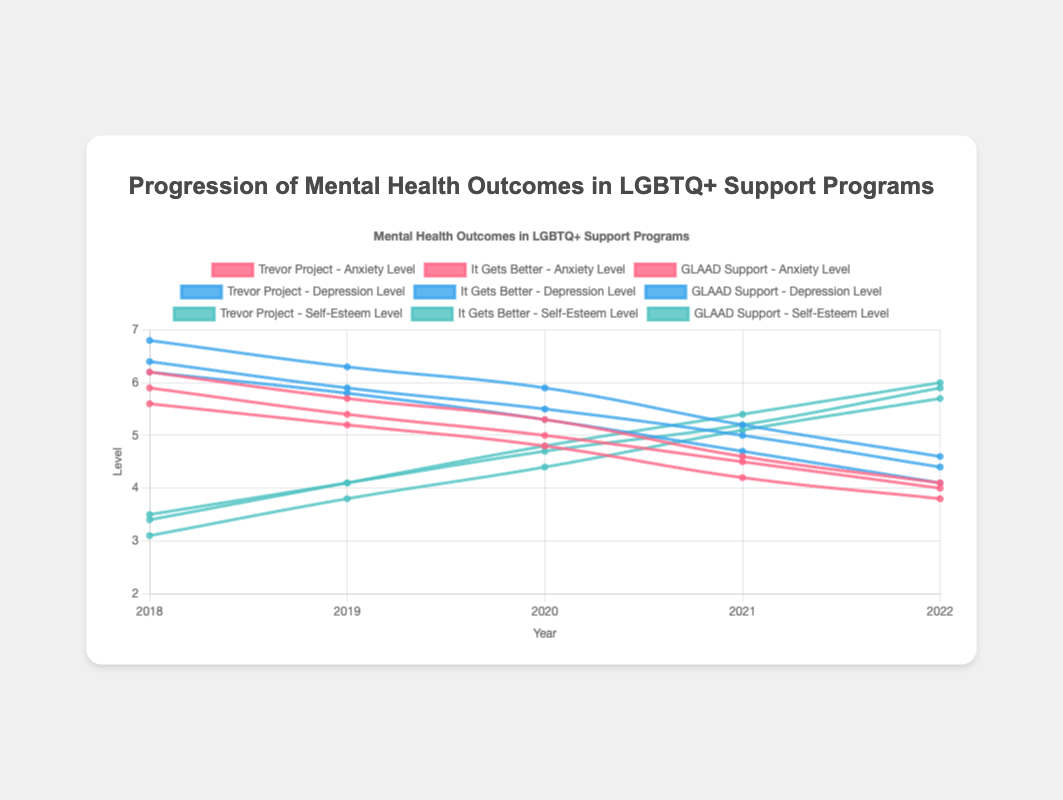What is the trend in anxiety levels for the Trevor Project from 2018 to 2022? The anxiety levels for the Trevor Project decrease year by year: 5.6 in 2018, 5.2 in 2019, 4.8 in 2020, 4.2 in 2021, and 3.8 in 2022.
Answer: Decreasing Which program showed the largest decrease in depression levels from 2018 to 2022? To find the largest decrease, look at the depression levels in 2018 and 2022 for each program and calculate the difference. The differences are: Trevor Project (6.2 to 4.1, a decrease of 2.1), It Gets Better (6.8 to 4.6, a decrease of 2.2), GLAAD Support (6.4 to 4.4, a decrease of 2.0). Therefore, It Gets Better shows the largest decrease.
Answer: It Gets Better Which program had the lowest self-esteem level in 2018? Compare the self-esteem levels of all programs for the year 2018: Trevor Project (3.4), It Gets Better (3.1), GLAAD Support (3.5). The lowest value is for It Gets Better.
Answer: It Gets Better What is the overall trend in self-esteem levels for the GLAAD Support program between 2018 and 2022? The self-esteem levels for the GLAAD Support program from 2018 to 2022 are: 3.5, 4.1, 4.7, 5.2, 5.9—showing a steady increase each year.
Answer: Increasing Between which two consecutive years did the Trevor Project show the largest drop in anxiety levels? Look at the anxiety levels for the Trevor Project over the years and calculate the year-to-year change: 2018-2019 (5.6 to 5.2, decrease of 0.4), 2019-2020 (5.2 to 4.8, decrease of 0.4), 2020-2021 (4.8 to 4.2, decrease of 0.6), 2021-2022 (4.2 to 3.8, decrease of 0.4). The largest drop is between 2020 and 2021.
Answer: 2020 and 2021 Which program had the highest depression level in 2019? Compare the depression levels of all programs for the year 2019: Trevor Project (5.8), It Gets Better (6.3), GLAAD Support (5.9). The highest value is for It Gets Better.
Answer: It Gets Better How did the self-esteem levels change for the "It Gets Better" program from 2018 to 2022? The self-esteem levels for the "It Gets Better" program from 2018 to 2022 are: 3.1, 3.8, 4.4, 5.1, 5.7—showing a consistent increase.
Answer: Increasing What is the median depression level for GLAAD Support over the years 2018-2022? To find the median, list the depression levels for GLAAD Support in ascending order: 4.4, 5.0, 5.5, 5.9, 6.4. The median is the middle value, which is 5.5.
Answer: 5.5 Which program showed the highest self-esteem level in 2022? Compare the self-esteem levels of all programs for the year 2022: Trevor Project (6.0), It Gets Better (5.7), GLAAD Support (5.9). The highest value is for Trevor Project.
Answer: Trevor Project 